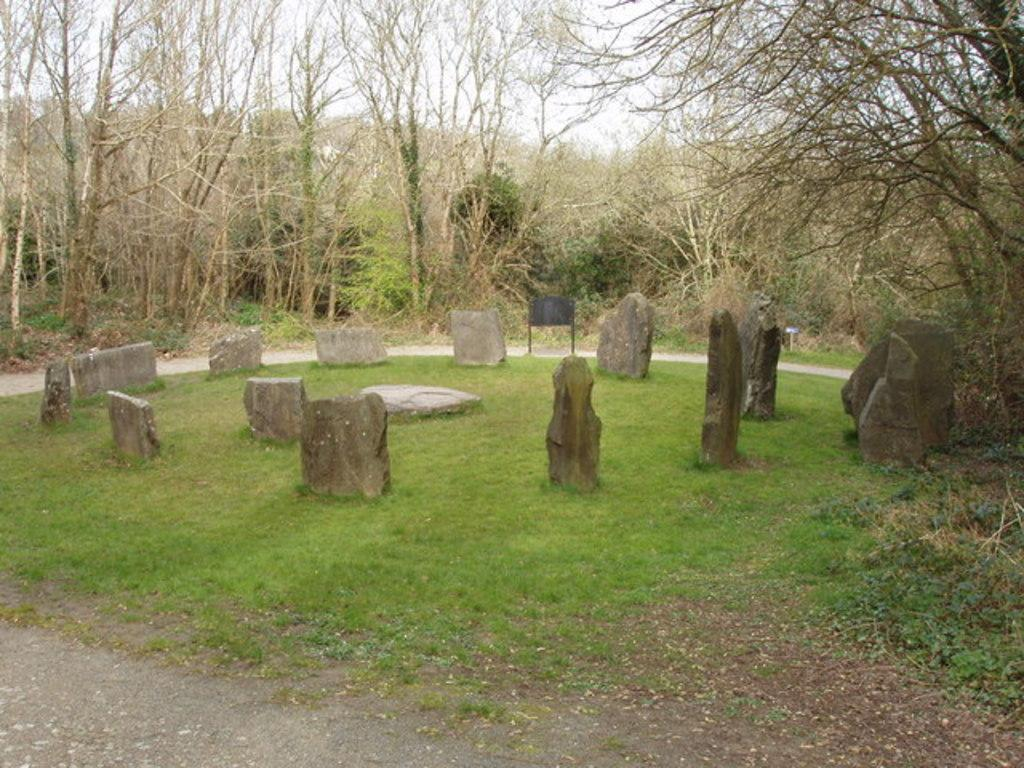What type of vegetation can be seen in the image? There are trees in the image. What objects are located in the middle of the image? There are stones in the middle of the image. What type of stew is being prepared in the image? There is no stew present in the image; it features trees and stones. How many shoes can be seen in the image? There are no shoes present in the image. 